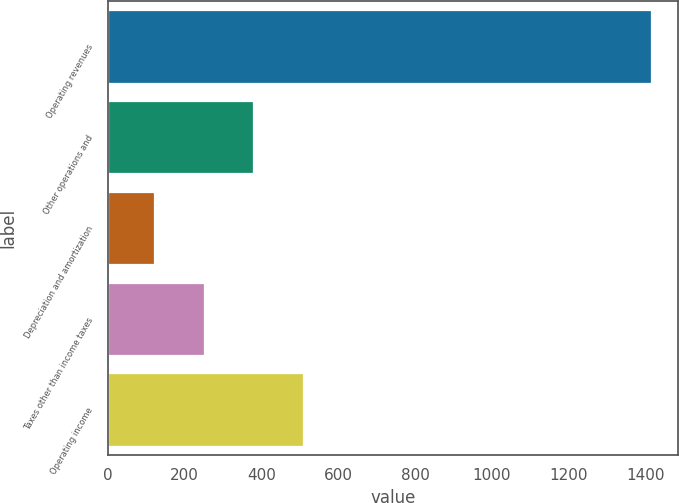Convert chart to OTSL. <chart><loc_0><loc_0><loc_500><loc_500><bar_chart><fcel>Operating revenues<fcel>Other operations and<fcel>Depreciation and amortization<fcel>Taxes other than income taxes<fcel>Operating income<nl><fcel>1415<fcel>379<fcel>120<fcel>249.5<fcel>508.5<nl></chart> 